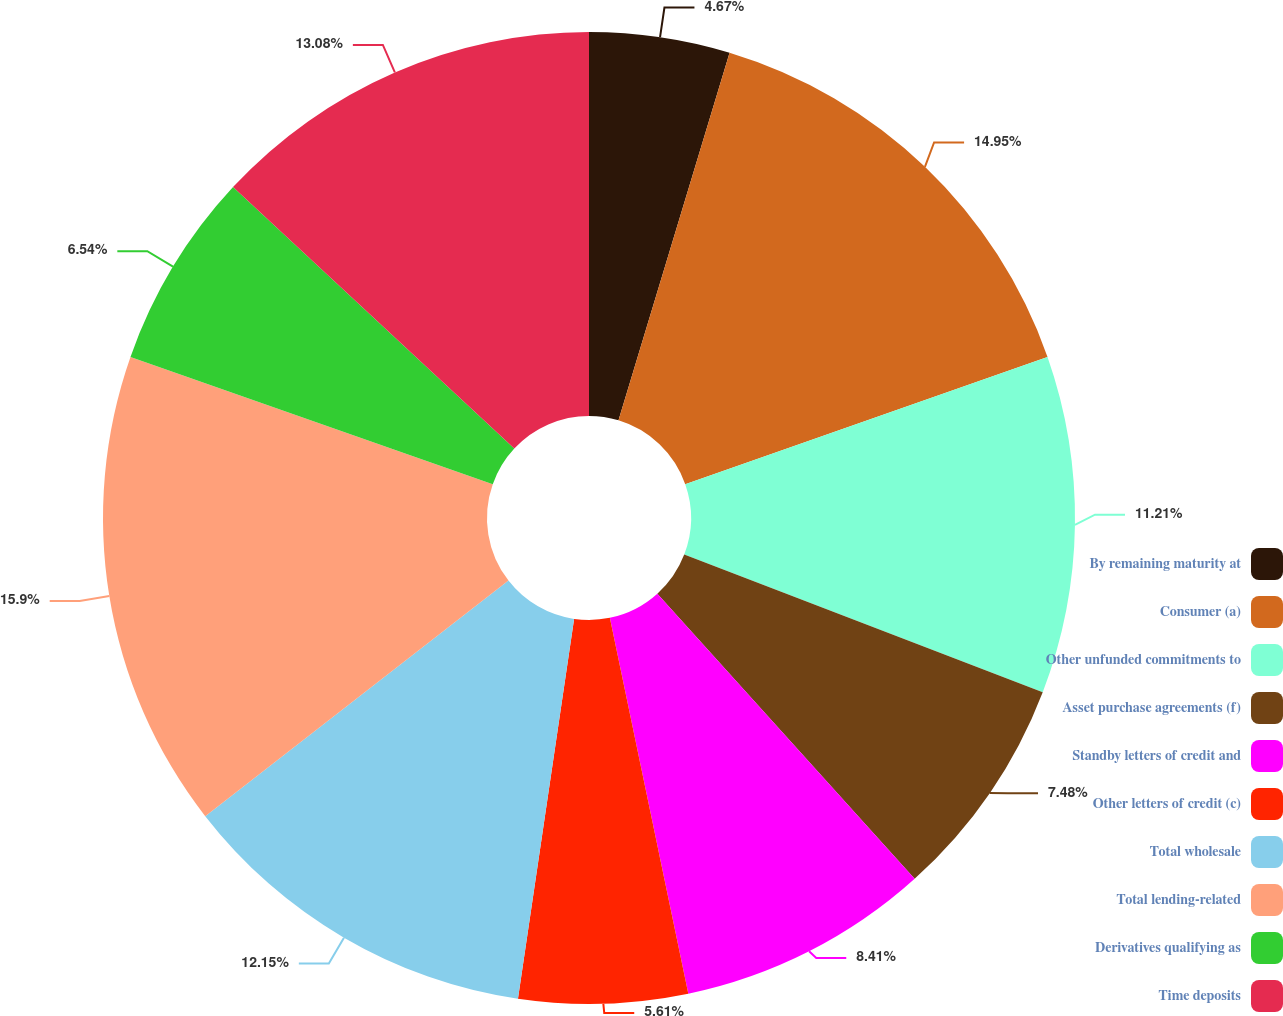<chart> <loc_0><loc_0><loc_500><loc_500><pie_chart><fcel>By remaining maturity at<fcel>Consumer (a)<fcel>Other unfunded commitments to<fcel>Asset purchase agreements (f)<fcel>Standby letters of credit and<fcel>Other letters of credit (c)<fcel>Total wholesale<fcel>Total lending-related<fcel>Derivatives qualifying as<fcel>Time deposits<nl><fcel>4.67%<fcel>14.95%<fcel>11.21%<fcel>7.48%<fcel>8.41%<fcel>5.61%<fcel>12.15%<fcel>15.89%<fcel>6.54%<fcel>13.08%<nl></chart> 